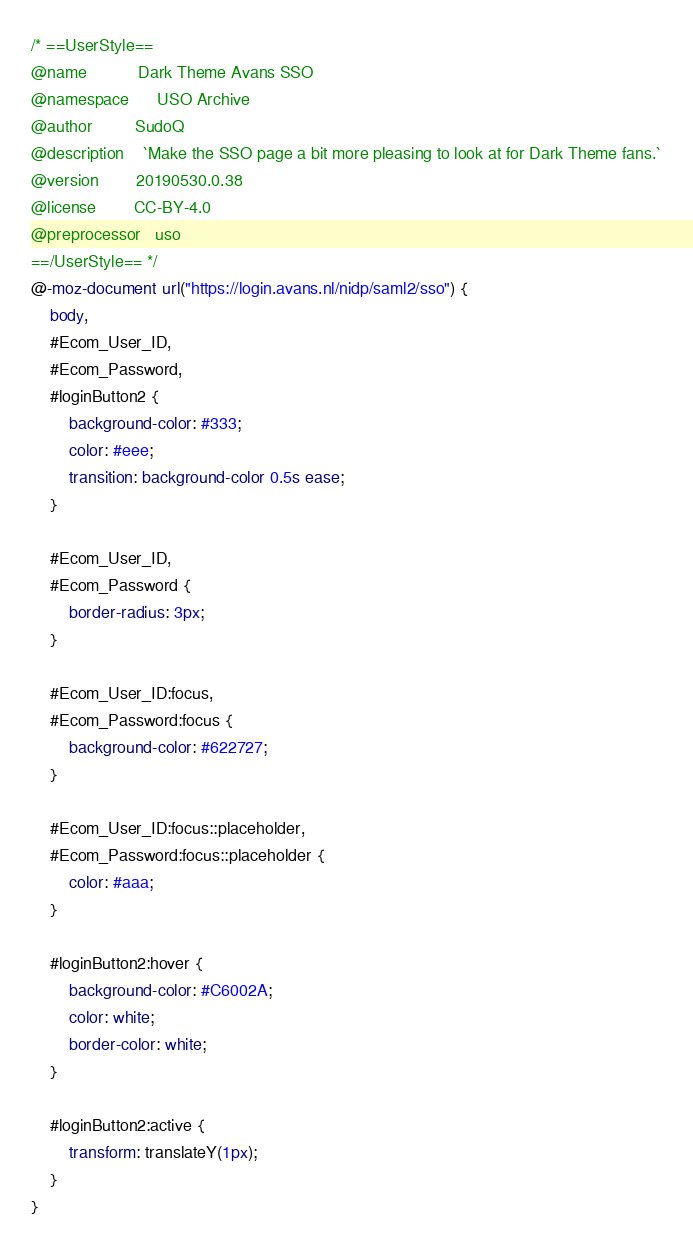Convert code to text. <code><loc_0><loc_0><loc_500><loc_500><_CSS_>/* ==UserStyle==
@name           Dark Theme Avans SSO
@namespace      USO Archive
@author         SudoQ
@description    `Make the SSO page a bit more pleasing to look at for Dark Theme fans.`
@version        20190530.0.38
@license        CC-BY-4.0
@preprocessor   uso
==/UserStyle== */
@-moz-document url("https://login.avans.nl/nidp/saml2/sso") {
    body,
    #Ecom_User_ID,
    #Ecom_Password,
    #loginButton2 {
        background-color: #333;
        color: #eee;
        transition: background-color 0.5s ease;
    }

    #Ecom_User_ID,
    #Ecom_Password {
        border-radius: 3px;
    }

    #Ecom_User_ID:focus,
    #Ecom_Password:focus {
        background-color: #622727;
    }

    #Ecom_User_ID:focus::placeholder,
    #Ecom_Password:focus::placeholder {
        color: #aaa;
    }

    #loginButton2:hover {
        background-color: #C6002A;
        color: white;
        border-color: white;
    }

    #loginButton2:active {
        transform: translateY(1px);
    }
}</code> 